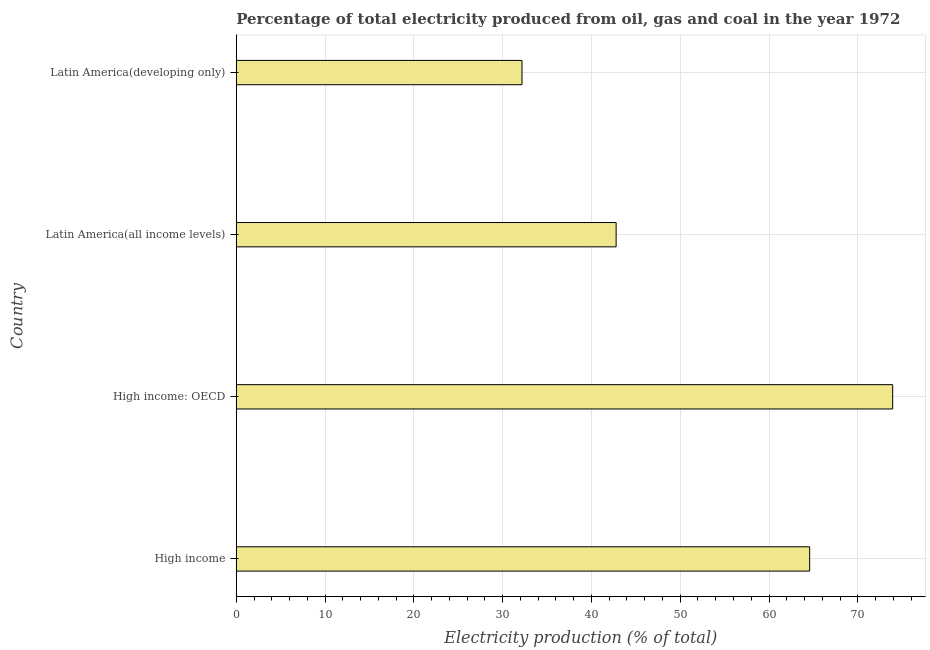What is the title of the graph?
Your answer should be very brief. Percentage of total electricity produced from oil, gas and coal in the year 1972. What is the label or title of the X-axis?
Your response must be concise. Electricity production (% of total). What is the label or title of the Y-axis?
Offer a terse response. Country. What is the electricity production in Latin America(all income levels)?
Offer a very short reply. 42.78. Across all countries, what is the maximum electricity production?
Provide a short and direct response. 73.93. Across all countries, what is the minimum electricity production?
Make the answer very short. 32.18. In which country was the electricity production maximum?
Give a very brief answer. High income: OECD. In which country was the electricity production minimum?
Your answer should be compact. Latin America(developing only). What is the sum of the electricity production?
Keep it short and to the point. 213.47. What is the difference between the electricity production in High income and High income: OECD?
Ensure brevity in your answer.  -9.35. What is the average electricity production per country?
Your answer should be compact. 53.37. What is the median electricity production?
Provide a short and direct response. 53.68. In how many countries, is the electricity production greater than 74 %?
Your response must be concise. 0. What is the ratio of the electricity production in High income to that in Latin America(all income levels)?
Your response must be concise. 1.51. Is the electricity production in High income: OECD less than that in Latin America(developing only)?
Keep it short and to the point. No. What is the difference between the highest and the second highest electricity production?
Your answer should be very brief. 9.35. What is the difference between the highest and the lowest electricity production?
Your answer should be very brief. 41.75. How many bars are there?
Keep it short and to the point. 4. What is the Electricity production (% of total) in High income?
Provide a succinct answer. 64.58. What is the Electricity production (% of total) of High income: OECD?
Offer a terse response. 73.93. What is the Electricity production (% of total) in Latin America(all income levels)?
Your answer should be compact. 42.78. What is the Electricity production (% of total) in Latin America(developing only)?
Offer a very short reply. 32.18. What is the difference between the Electricity production (% of total) in High income and High income: OECD?
Provide a succinct answer. -9.35. What is the difference between the Electricity production (% of total) in High income and Latin America(all income levels)?
Your answer should be very brief. 21.8. What is the difference between the Electricity production (% of total) in High income and Latin America(developing only)?
Provide a succinct answer. 32.4. What is the difference between the Electricity production (% of total) in High income: OECD and Latin America(all income levels)?
Your response must be concise. 31.14. What is the difference between the Electricity production (% of total) in High income: OECD and Latin America(developing only)?
Your answer should be compact. 41.75. What is the difference between the Electricity production (% of total) in Latin America(all income levels) and Latin America(developing only)?
Your answer should be very brief. 10.6. What is the ratio of the Electricity production (% of total) in High income to that in High income: OECD?
Make the answer very short. 0.87. What is the ratio of the Electricity production (% of total) in High income to that in Latin America(all income levels)?
Your answer should be very brief. 1.51. What is the ratio of the Electricity production (% of total) in High income to that in Latin America(developing only)?
Keep it short and to the point. 2.01. What is the ratio of the Electricity production (% of total) in High income: OECD to that in Latin America(all income levels)?
Make the answer very short. 1.73. What is the ratio of the Electricity production (% of total) in High income: OECD to that in Latin America(developing only)?
Offer a very short reply. 2.3. What is the ratio of the Electricity production (% of total) in Latin America(all income levels) to that in Latin America(developing only)?
Your answer should be very brief. 1.33. 